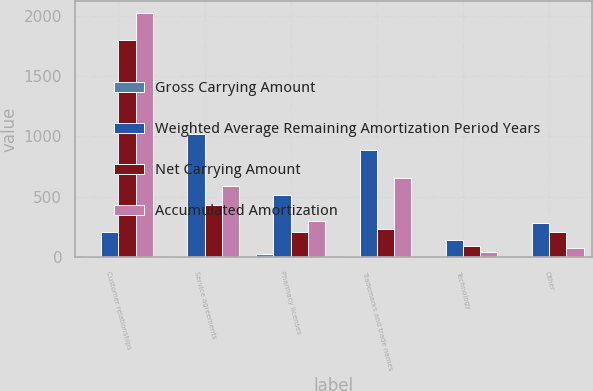<chart> <loc_0><loc_0><loc_500><loc_500><stacked_bar_chart><ecel><fcel>Customer relationships<fcel>Service agreements<fcel>Pharmacy licenses<fcel>Trademarks and trade names<fcel>Technology<fcel>Other<nl><fcel>Gross Carrying Amount<fcel>12<fcel>11<fcel>26<fcel>13<fcel>4<fcel>5<nl><fcel>Weighted Average Remaining Amortization Period Years<fcel>209<fcel>1017<fcel>513<fcel>887<fcel>141<fcel>288<nl><fcel>Net Carrying Amount<fcel>1801<fcel>430<fcel>209<fcel>232<fcel>94<fcel>209<nl><fcel>Accumulated Amortization<fcel>2017<fcel>587<fcel>304<fcel>655<fcel>47<fcel>79<nl></chart> 